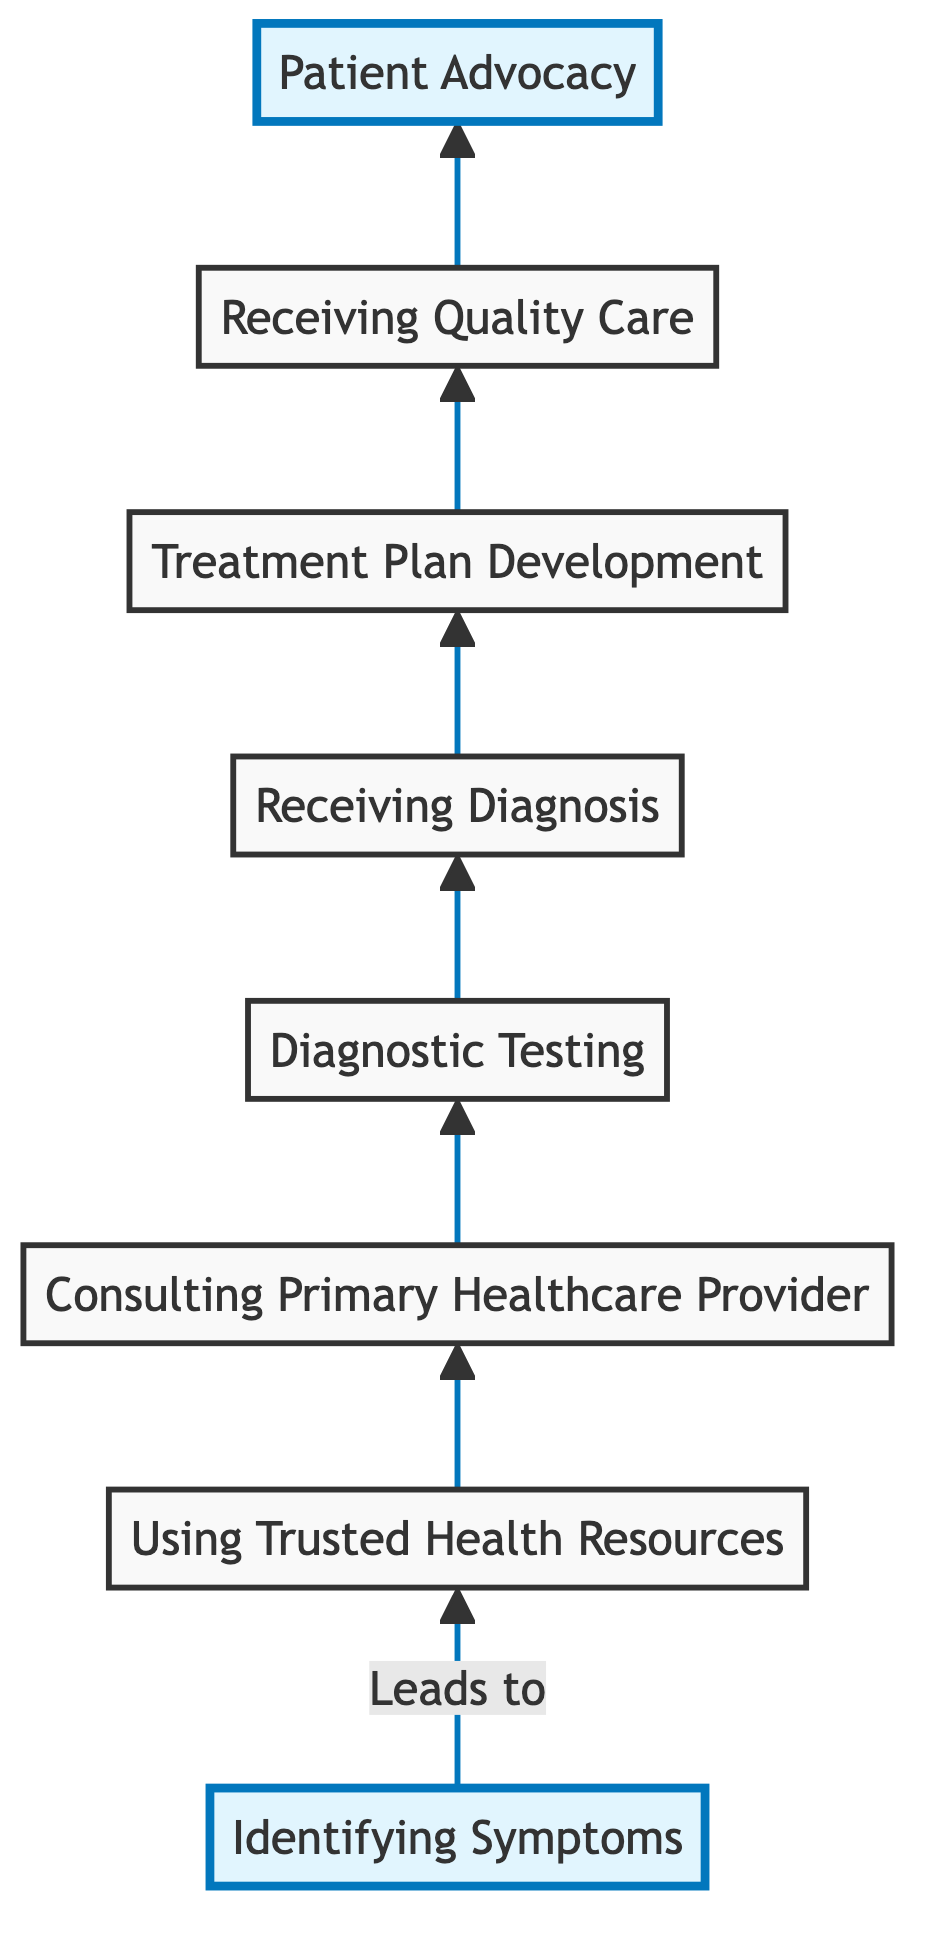What is the first step to navigating the healthcare system? The first step illustrated in the diagram is "Identifying Symptoms." This is the starting point of the flow, indicating the initial action a patient should take.
Answer: Identifying Symptoms How many nodes are there in the diagram? The diagram contains a total of eight nodes representing the different steps in navigating the healthcare system, from "Identifying Symptoms" to "Patient Advocacy."
Answer: Eight Which step follows "Diagnostic Testing"? According to the flow, "Receiving Diagnosis" directly follows the "Diagnostic Testing" node. This indicates that after testing, the next step is to receive a diagnosis based on those tests.
Answer: Receiving Diagnosis What resources can be consulted after identifying symptoms? After identifying symptoms, the next step is to use "Trusted Health Resources," which involve consulting reliable sources for initial information on the symptoms noted.
Answer: Using Trusted Health Resources What is the last step in the healthcare navigation process? The final action depicted in the flow is "Patient Advocacy," which indicates the conclusion of the navigation process where individuals engage with organizations to ensure proper care and rights.
Answer: Patient Advocacy Which two steps are highlighted in the diagram? The diagram highlights "Identifying Symptoms" at the bottom and "Patient Advocacy" at the top, indicating their significance as starting and concluding points in the process.
Answer: Identifying Symptoms and Patient Advocacy What precedes "Treatment Plan Development"? The step that comes before "Treatment Plan Development" is "Receiving Diagnosis," indicating that a diagnosis is essential before any treatment planning can take place.
Answer: Receiving Diagnosis Which examples are given under "Receiving Quality Care"? The examples listed under "Receiving Quality Care" include "Hospital stays," "Outpatient care," and "Home health services," showing various forms of quality healthcare a patient might receive.
Answer: Hospital stays, Outpatient care, Home health services 